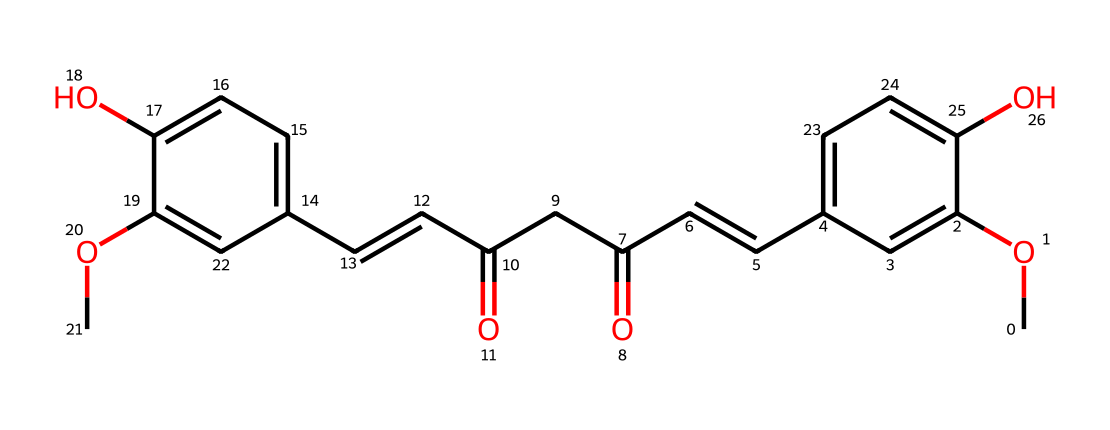What is the molecular formula of curcumin? To determine the molecular formula from the SMILES representation, we can count the number of each type of atom present: it's composed of 21 carbon (C) atoms, 20 hydrogen (H) atoms, and 6 oxygen (O) atoms. Thus, the molecular formula is derived from the counts of each atom.
Answer: C21H20O6 How many hydroxyl (-OH) groups are present in curcumin? By examining the SMILES representation, we can see two distinct -OH groups attached to the benzene rings (noted as 'O' connected to the 'c' in two places). Therefore, there are two hydroxyl groups in this molecular structure.
Answer: 2 What type of functional groups are present in curcumin? In the SMILES, we notice -OH groups (hydroxyl), -C=O (carbonyl from the ketone structures), and -C=C (alkene). Identifying these parts indicates that curcumin contains multiple functional groups, specifically including hydroxyl, carbonyl, and alkene groups.
Answer: hydroxyl, carbonyl, alkene Which part of the structure contributes to its antioxidant properties? The antioxidant properties of curcumin are largely attributed to the presence of the hydroxyl (-OH) groups, which can donate hydrogen atoms and neutralize free radicals. While the entire structure contributes to its overall function, the -OH groups are significant for antioxidant activity.
Answer: hydroxyl groups What is the type of chemical bond primarily present in curcumin? Analyzing the structure, curcumin features multiple types of bonds including single (σ) bonds, double (π) bonds evidenced by C=C and C=O connections. However, the most common bond type observed throughout is the single covalent bond.
Answer: single covalent bonds How does the presence of conjugated double bonds affect curcumin's stability? The alternating double bonds in the structure create a system of resonance that provides stability. Electrons can delocalize across the conjugated system, lowering the energy of the molecule, which contributes to its stability and biological activity, particularly in antioxidant functions.
Answer: resonance stabilization 